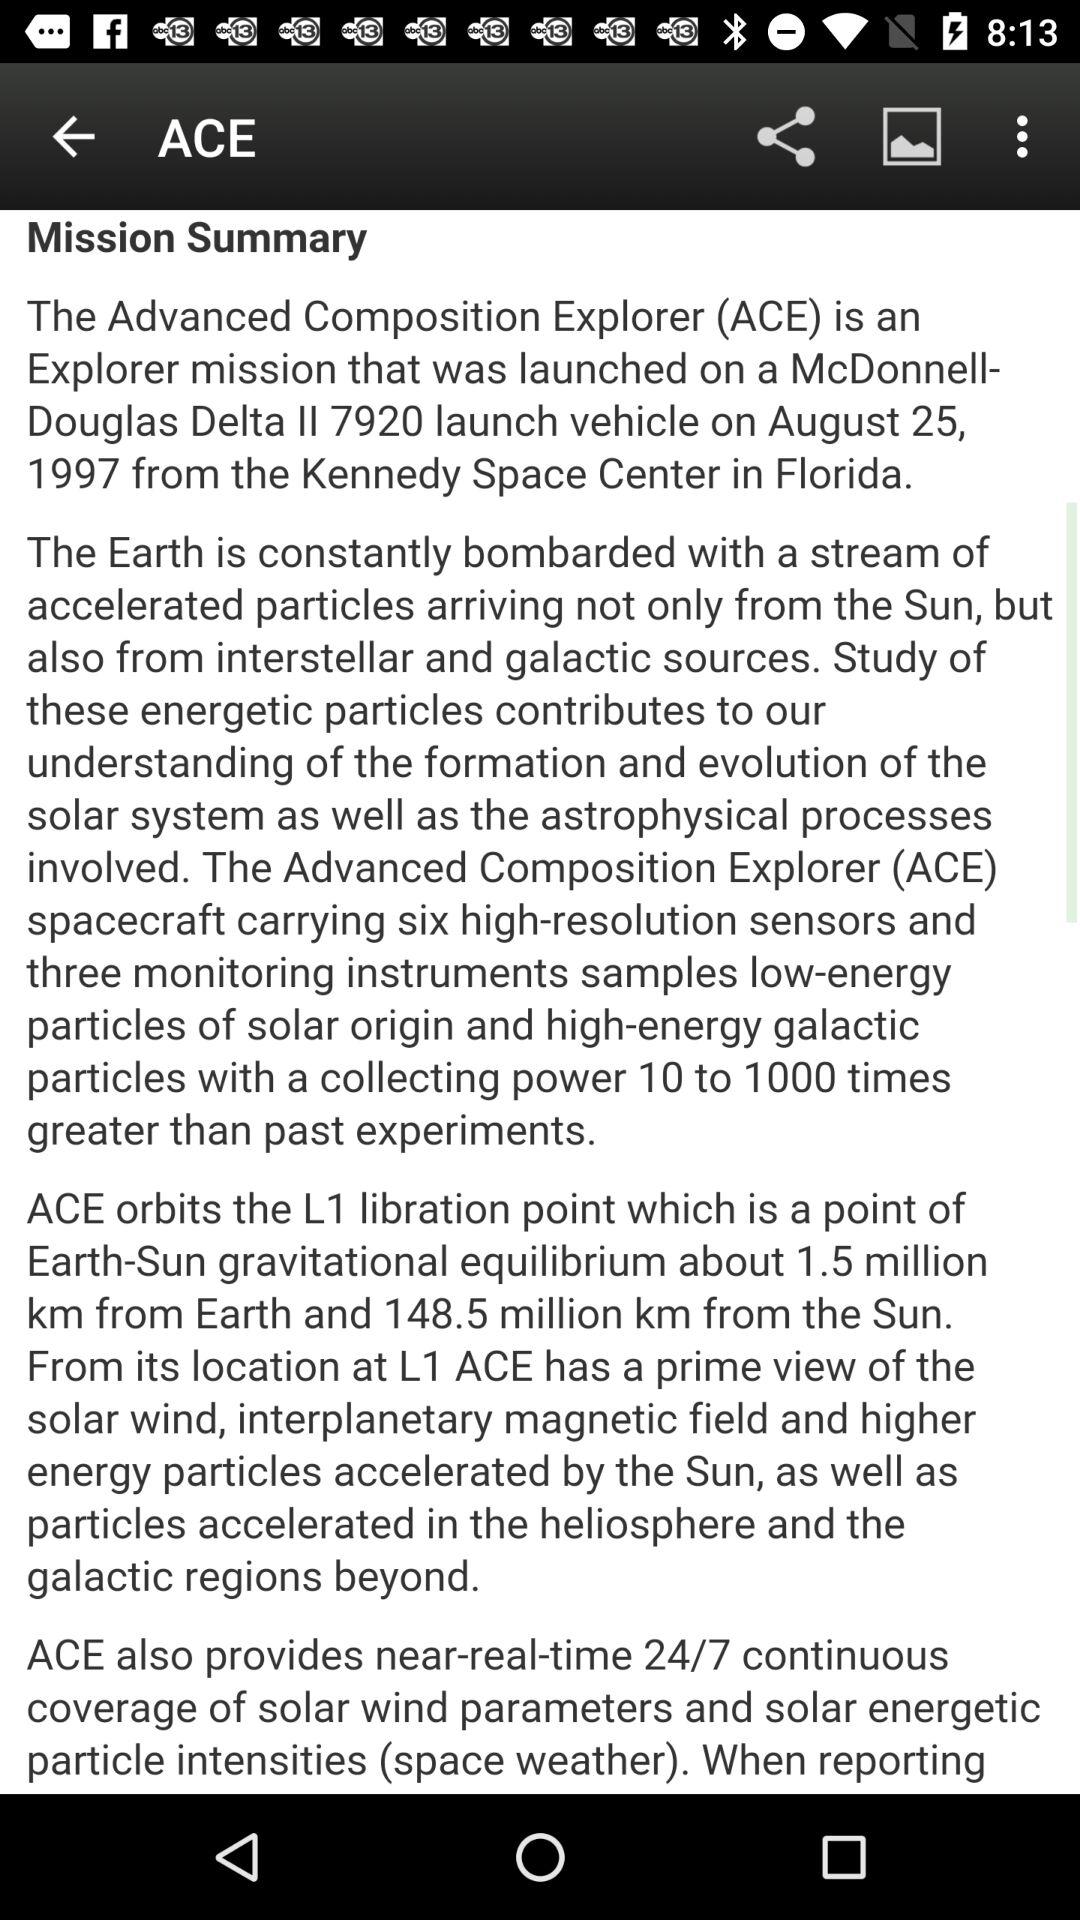On what date was the "ACE" mission launched? The date is August 25, 1997. 